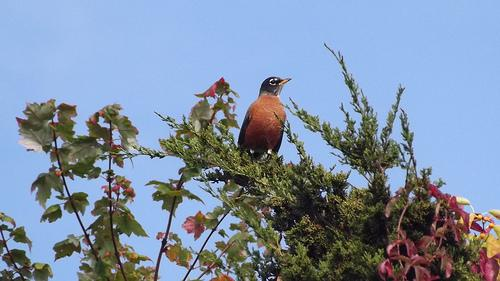Question: what color is the sky?
Choices:
A. Blue.
B. Clear blue.
C. Dark blue.
D. Orange.
Answer with the letter. Answer: B Question: how many birds are in the tree?
Choices:
A. At least one.
B. Two.
C. Three.
D. Four.
Answer with the letter. Answer: A Question: what is high in the tree?
Choices:
A. A bird.
B. A squirrel.
C. A monkey.
D. A bat.
Answer with the letter. Answer: A 